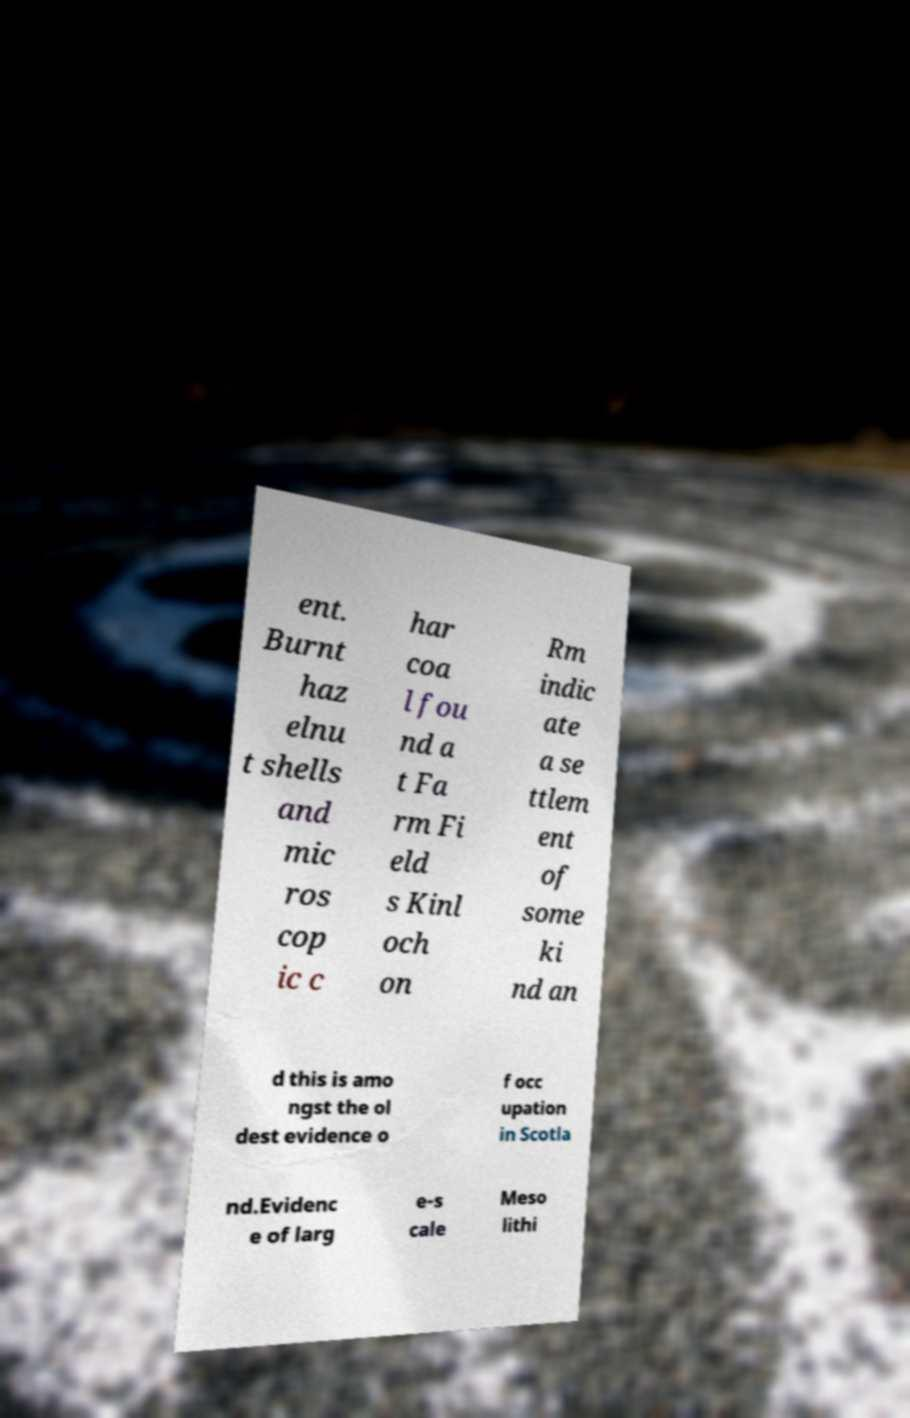There's text embedded in this image that I need extracted. Can you transcribe it verbatim? ent. Burnt haz elnu t shells and mic ros cop ic c har coa l fou nd a t Fa rm Fi eld s Kinl och on Rm indic ate a se ttlem ent of some ki nd an d this is amo ngst the ol dest evidence o f occ upation in Scotla nd.Evidenc e of larg e-s cale Meso lithi 